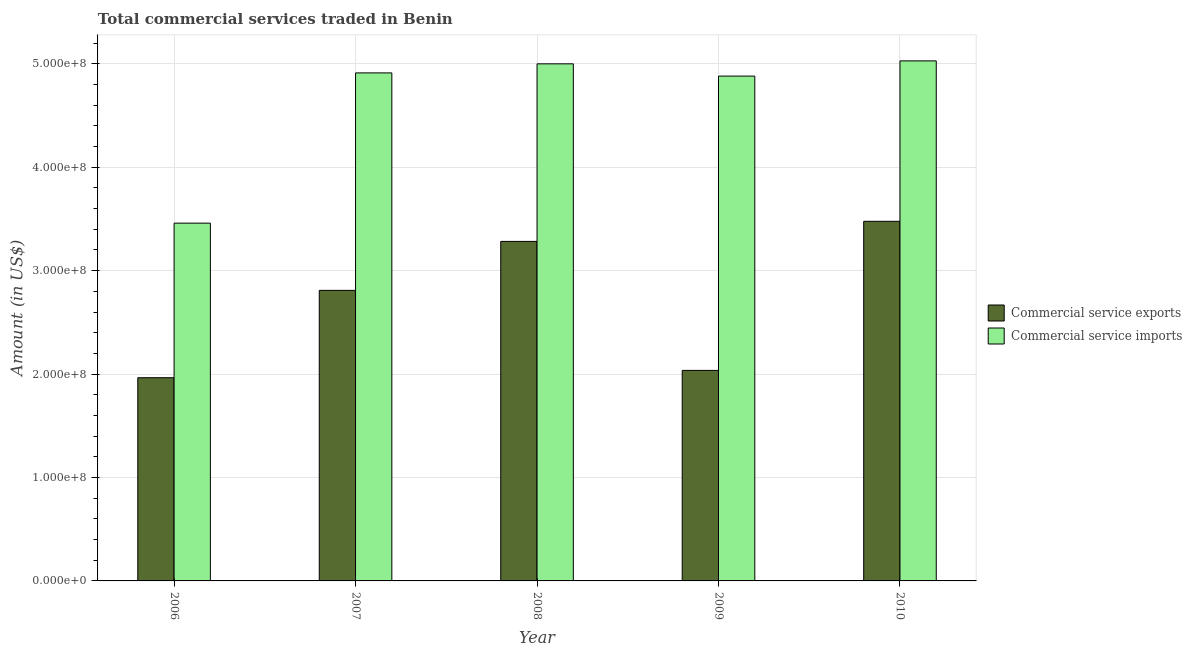How many different coloured bars are there?
Give a very brief answer. 2. How many groups of bars are there?
Make the answer very short. 5. Are the number of bars per tick equal to the number of legend labels?
Your response must be concise. Yes. How many bars are there on the 2nd tick from the left?
Ensure brevity in your answer.  2. How many bars are there on the 3rd tick from the right?
Give a very brief answer. 2. What is the label of the 5th group of bars from the left?
Provide a short and direct response. 2010. In how many cases, is the number of bars for a given year not equal to the number of legend labels?
Ensure brevity in your answer.  0. What is the amount of commercial service exports in 2010?
Ensure brevity in your answer.  3.48e+08. Across all years, what is the maximum amount of commercial service exports?
Offer a terse response. 3.48e+08. Across all years, what is the minimum amount of commercial service exports?
Your answer should be compact. 1.96e+08. In which year was the amount of commercial service imports maximum?
Your response must be concise. 2010. In which year was the amount of commercial service imports minimum?
Make the answer very short. 2006. What is the total amount of commercial service exports in the graph?
Your answer should be compact. 1.36e+09. What is the difference between the amount of commercial service exports in 2007 and that in 2008?
Your answer should be very brief. -4.74e+07. What is the difference between the amount of commercial service exports in 2010 and the amount of commercial service imports in 2007?
Your response must be concise. 6.68e+07. What is the average amount of commercial service imports per year?
Provide a succinct answer. 4.66e+08. In the year 2008, what is the difference between the amount of commercial service exports and amount of commercial service imports?
Your answer should be compact. 0. In how many years, is the amount of commercial service imports greater than 200000000 US$?
Your answer should be compact. 5. What is the ratio of the amount of commercial service imports in 2007 to that in 2009?
Ensure brevity in your answer.  1.01. Is the amount of commercial service imports in 2006 less than that in 2010?
Provide a succinct answer. Yes. What is the difference between the highest and the second highest amount of commercial service imports?
Your answer should be very brief. 2.87e+06. What is the difference between the highest and the lowest amount of commercial service exports?
Provide a short and direct response. 1.51e+08. In how many years, is the amount of commercial service imports greater than the average amount of commercial service imports taken over all years?
Provide a short and direct response. 4. What does the 2nd bar from the left in 2007 represents?
Your response must be concise. Commercial service imports. What does the 2nd bar from the right in 2007 represents?
Keep it short and to the point. Commercial service exports. How many bars are there?
Give a very brief answer. 10. Are all the bars in the graph horizontal?
Provide a short and direct response. No. How many years are there in the graph?
Keep it short and to the point. 5. What is the difference between two consecutive major ticks on the Y-axis?
Keep it short and to the point. 1.00e+08. Does the graph contain grids?
Keep it short and to the point. Yes. Where does the legend appear in the graph?
Offer a very short reply. Center right. What is the title of the graph?
Offer a very short reply. Total commercial services traded in Benin. Does "Goods" appear as one of the legend labels in the graph?
Your answer should be very brief. No. What is the label or title of the X-axis?
Offer a terse response. Year. What is the label or title of the Y-axis?
Your response must be concise. Amount (in US$). What is the Amount (in US$) in Commercial service exports in 2006?
Make the answer very short. 1.96e+08. What is the Amount (in US$) of Commercial service imports in 2006?
Provide a succinct answer. 3.46e+08. What is the Amount (in US$) of Commercial service exports in 2007?
Offer a terse response. 2.81e+08. What is the Amount (in US$) in Commercial service imports in 2007?
Your response must be concise. 4.91e+08. What is the Amount (in US$) of Commercial service exports in 2008?
Ensure brevity in your answer.  3.28e+08. What is the Amount (in US$) of Commercial service imports in 2008?
Give a very brief answer. 5.00e+08. What is the Amount (in US$) of Commercial service exports in 2009?
Provide a short and direct response. 2.04e+08. What is the Amount (in US$) of Commercial service imports in 2009?
Offer a terse response. 4.88e+08. What is the Amount (in US$) of Commercial service exports in 2010?
Offer a very short reply. 3.48e+08. What is the Amount (in US$) in Commercial service imports in 2010?
Offer a very short reply. 5.03e+08. Across all years, what is the maximum Amount (in US$) in Commercial service exports?
Ensure brevity in your answer.  3.48e+08. Across all years, what is the maximum Amount (in US$) of Commercial service imports?
Your answer should be compact. 5.03e+08. Across all years, what is the minimum Amount (in US$) in Commercial service exports?
Provide a succinct answer. 1.96e+08. Across all years, what is the minimum Amount (in US$) in Commercial service imports?
Your answer should be compact. 3.46e+08. What is the total Amount (in US$) in Commercial service exports in the graph?
Provide a succinct answer. 1.36e+09. What is the total Amount (in US$) of Commercial service imports in the graph?
Your response must be concise. 2.33e+09. What is the difference between the Amount (in US$) of Commercial service exports in 2006 and that in 2007?
Your answer should be compact. -8.45e+07. What is the difference between the Amount (in US$) of Commercial service imports in 2006 and that in 2007?
Ensure brevity in your answer.  -1.45e+08. What is the difference between the Amount (in US$) in Commercial service exports in 2006 and that in 2008?
Make the answer very short. -1.32e+08. What is the difference between the Amount (in US$) in Commercial service imports in 2006 and that in 2008?
Provide a short and direct response. -1.54e+08. What is the difference between the Amount (in US$) in Commercial service exports in 2006 and that in 2009?
Your answer should be compact. -7.08e+06. What is the difference between the Amount (in US$) in Commercial service imports in 2006 and that in 2009?
Ensure brevity in your answer.  -1.42e+08. What is the difference between the Amount (in US$) in Commercial service exports in 2006 and that in 2010?
Offer a terse response. -1.51e+08. What is the difference between the Amount (in US$) in Commercial service imports in 2006 and that in 2010?
Provide a short and direct response. -1.57e+08. What is the difference between the Amount (in US$) of Commercial service exports in 2007 and that in 2008?
Provide a succinct answer. -4.74e+07. What is the difference between the Amount (in US$) of Commercial service imports in 2007 and that in 2008?
Provide a short and direct response. -8.76e+06. What is the difference between the Amount (in US$) of Commercial service exports in 2007 and that in 2009?
Keep it short and to the point. 7.74e+07. What is the difference between the Amount (in US$) in Commercial service imports in 2007 and that in 2009?
Keep it short and to the point. 3.08e+06. What is the difference between the Amount (in US$) in Commercial service exports in 2007 and that in 2010?
Make the answer very short. -6.68e+07. What is the difference between the Amount (in US$) in Commercial service imports in 2007 and that in 2010?
Your answer should be compact. -1.16e+07. What is the difference between the Amount (in US$) of Commercial service exports in 2008 and that in 2009?
Offer a very short reply. 1.25e+08. What is the difference between the Amount (in US$) in Commercial service imports in 2008 and that in 2009?
Make the answer very short. 1.18e+07. What is the difference between the Amount (in US$) of Commercial service exports in 2008 and that in 2010?
Provide a succinct answer. -1.94e+07. What is the difference between the Amount (in US$) in Commercial service imports in 2008 and that in 2010?
Offer a very short reply. -2.87e+06. What is the difference between the Amount (in US$) in Commercial service exports in 2009 and that in 2010?
Offer a terse response. -1.44e+08. What is the difference between the Amount (in US$) of Commercial service imports in 2009 and that in 2010?
Give a very brief answer. -1.47e+07. What is the difference between the Amount (in US$) of Commercial service exports in 2006 and the Amount (in US$) of Commercial service imports in 2007?
Offer a very short reply. -2.95e+08. What is the difference between the Amount (in US$) of Commercial service exports in 2006 and the Amount (in US$) of Commercial service imports in 2008?
Your answer should be very brief. -3.04e+08. What is the difference between the Amount (in US$) of Commercial service exports in 2006 and the Amount (in US$) of Commercial service imports in 2009?
Make the answer very short. -2.92e+08. What is the difference between the Amount (in US$) in Commercial service exports in 2006 and the Amount (in US$) in Commercial service imports in 2010?
Offer a very short reply. -3.06e+08. What is the difference between the Amount (in US$) in Commercial service exports in 2007 and the Amount (in US$) in Commercial service imports in 2008?
Provide a short and direct response. -2.19e+08. What is the difference between the Amount (in US$) of Commercial service exports in 2007 and the Amount (in US$) of Commercial service imports in 2009?
Your response must be concise. -2.07e+08. What is the difference between the Amount (in US$) of Commercial service exports in 2007 and the Amount (in US$) of Commercial service imports in 2010?
Your answer should be very brief. -2.22e+08. What is the difference between the Amount (in US$) of Commercial service exports in 2008 and the Amount (in US$) of Commercial service imports in 2009?
Offer a terse response. -1.60e+08. What is the difference between the Amount (in US$) of Commercial service exports in 2008 and the Amount (in US$) of Commercial service imports in 2010?
Offer a terse response. -1.75e+08. What is the difference between the Amount (in US$) of Commercial service exports in 2009 and the Amount (in US$) of Commercial service imports in 2010?
Keep it short and to the point. -2.99e+08. What is the average Amount (in US$) in Commercial service exports per year?
Offer a terse response. 2.71e+08. What is the average Amount (in US$) of Commercial service imports per year?
Give a very brief answer. 4.66e+08. In the year 2006, what is the difference between the Amount (in US$) of Commercial service exports and Amount (in US$) of Commercial service imports?
Provide a short and direct response. -1.49e+08. In the year 2007, what is the difference between the Amount (in US$) in Commercial service exports and Amount (in US$) in Commercial service imports?
Give a very brief answer. -2.10e+08. In the year 2008, what is the difference between the Amount (in US$) in Commercial service exports and Amount (in US$) in Commercial service imports?
Offer a terse response. -1.72e+08. In the year 2009, what is the difference between the Amount (in US$) of Commercial service exports and Amount (in US$) of Commercial service imports?
Provide a short and direct response. -2.85e+08. In the year 2010, what is the difference between the Amount (in US$) in Commercial service exports and Amount (in US$) in Commercial service imports?
Your answer should be compact. -1.55e+08. What is the ratio of the Amount (in US$) of Commercial service exports in 2006 to that in 2007?
Your response must be concise. 0.7. What is the ratio of the Amount (in US$) of Commercial service imports in 2006 to that in 2007?
Offer a very short reply. 0.7. What is the ratio of the Amount (in US$) in Commercial service exports in 2006 to that in 2008?
Ensure brevity in your answer.  0.6. What is the ratio of the Amount (in US$) in Commercial service imports in 2006 to that in 2008?
Your response must be concise. 0.69. What is the ratio of the Amount (in US$) in Commercial service exports in 2006 to that in 2009?
Your answer should be compact. 0.97. What is the ratio of the Amount (in US$) of Commercial service imports in 2006 to that in 2009?
Offer a terse response. 0.71. What is the ratio of the Amount (in US$) of Commercial service exports in 2006 to that in 2010?
Your answer should be compact. 0.56. What is the ratio of the Amount (in US$) in Commercial service imports in 2006 to that in 2010?
Ensure brevity in your answer.  0.69. What is the ratio of the Amount (in US$) of Commercial service exports in 2007 to that in 2008?
Your answer should be very brief. 0.86. What is the ratio of the Amount (in US$) in Commercial service imports in 2007 to that in 2008?
Your answer should be very brief. 0.98. What is the ratio of the Amount (in US$) of Commercial service exports in 2007 to that in 2009?
Ensure brevity in your answer.  1.38. What is the ratio of the Amount (in US$) of Commercial service exports in 2007 to that in 2010?
Provide a short and direct response. 0.81. What is the ratio of the Amount (in US$) of Commercial service imports in 2007 to that in 2010?
Provide a short and direct response. 0.98. What is the ratio of the Amount (in US$) in Commercial service exports in 2008 to that in 2009?
Your response must be concise. 1.61. What is the ratio of the Amount (in US$) of Commercial service imports in 2008 to that in 2009?
Give a very brief answer. 1.02. What is the ratio of the Amount (in US$) of Commercial service exports in 2008 to that in 2010?
Offer a very short reply. 0.94. What is the ratio of the Amount (in US$) of Commercial service exports in 2009 to that in 2010?
Your answer should be very brief. 0.59. What is the ratio of the Amount (in US$) of Commercial service imports in 2009 to that in 2010?
Offer a terse response. 0.97. What is the difference between the highest and the second highest Amount (in US$) in Commercial service exports?
Give a very brief answer. 1.94e+07. What is the difference between the highest and the second highest Amount (in US$) of Commercial service imports?
Offer a very short reply. 2.87e+06. What is the difference between the highest and the lowest Amount (in US$) of Commercial service exports?
Make the answer very short. 1.51e+08. What is the difference between the highest and the lowest Amount (in US$) of Commercial service imports?
Keep it short and to the point. 1.57e+08. 